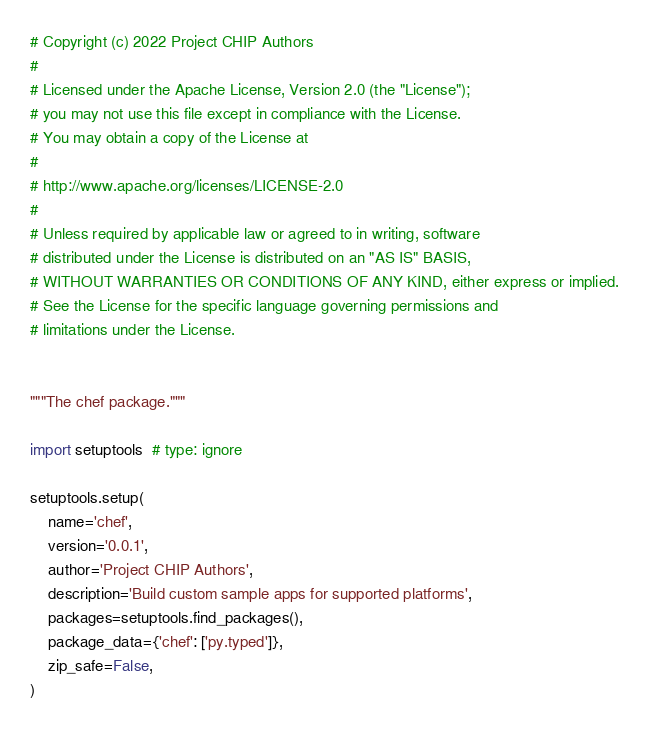Convert code to text. <code><loc_0><loc_0><loc_500><loc_500><_Python_># Copyright (c) 2022 Project CHIP Authors
#
# Licensed under the Apache License, Version 2.0 (the "License");
# you may not use this file except in compliance with the License.
# You may obtain a copy of the License at
#
# http://www.apache.org/licenses/LICENSE-2.0
#
# Unless required by applicable law or agreed to in writing, software
# distributed under the License is distributed on an "AS IS" BASIS,
# WITHOUT WARRANTIES OR CONDITIONS OF ANY KIND, either express or implied.
# See the License for the specific language governing permissions and
# limitations under the License.


"""The chef package."""

import setuptools  # type: ignore

setuptools.setup(
    name='chef',
    version='0.0.1',
    author='Project CHIP Authors',
    description='Build custom sample apps for supported platforms',
    packages=setuptools.find_packages(),
    package_data={'chef': ['py.typed']},
    zip_safe=False,
)
</code> 